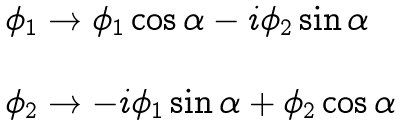<formula> <loc_0><loc_0><loc_500><loc_500>\begin{array} { l } \phi _ { 1 } \rightarrow \phi _ { 1 } \cos \alpha - i \phi _ { 2 } \sin \alpha \\ \\ \phi _ { 2 } \rightarrow - i \phi _ { 1 } \sin \alpha + \phi _ { 2 } \cos \alpha \end{array}</formula> 